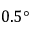Convert formula to latex. <formula><loc_0><loc_0><loc_500><loc_500>0 . 5 \text  degree</formula> 